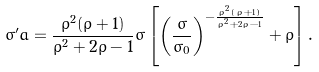Convert formula to latex. <formula><loc_0><loc_0><loc_500><loc_500>\sigma ^ { \prime } a = \frac { \rho ^ { 2 } ( \rho + 1 ) } { \rho ^ { 2 } + 2 \rho - 1 } \sigma \left [ \left ( \frac { \sigma } { \sigma _ { 0 } } \right ) ^ { - \frac { \rho ^ { 2 } \left ( \rho + 1 \right ) } { \rho ^ { 2 } + 2 \rho - 1 } } + \rho \right ] .</formula> 